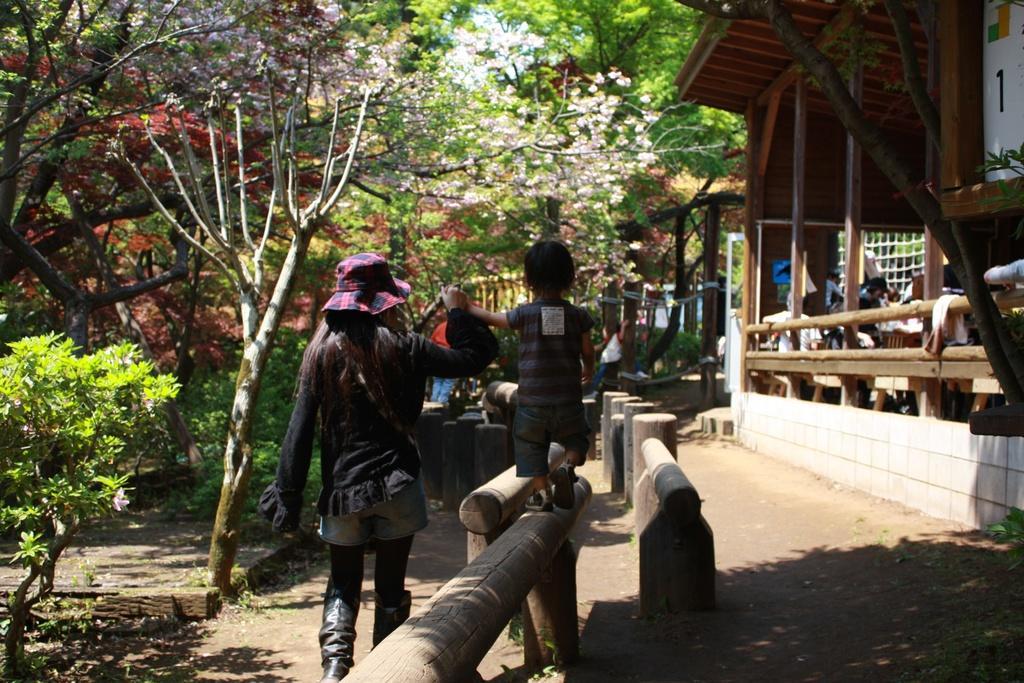In one or two sentences, can you explain what this image depicts? In the middle a woman is walking by making the baby to walk on these things, she wore hat, on the left side there are trees. On the right side there is a wooden house. 